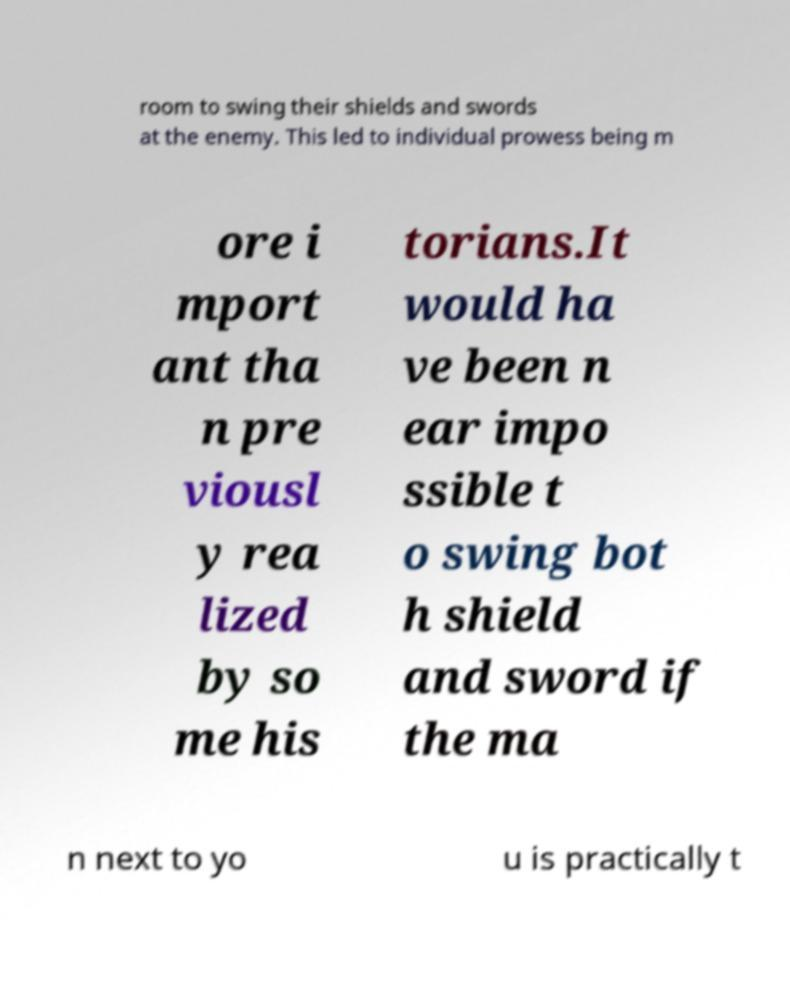Can you accurately transcribe the text from the provided image for me? room to swing their shields and swords at the enemy. This led to individual prowess being m ore i mport ant tha n pre viousl y rea lized by so me his torians.It would ha ve been n ear impo ssible t o swing bot h shield and sword if the ma n next to yo u is practically t 